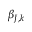Convert formula to latex. <formula><loc_0><loc_0><loc_500><loc_500>\beta _ { J , k }</formula> 